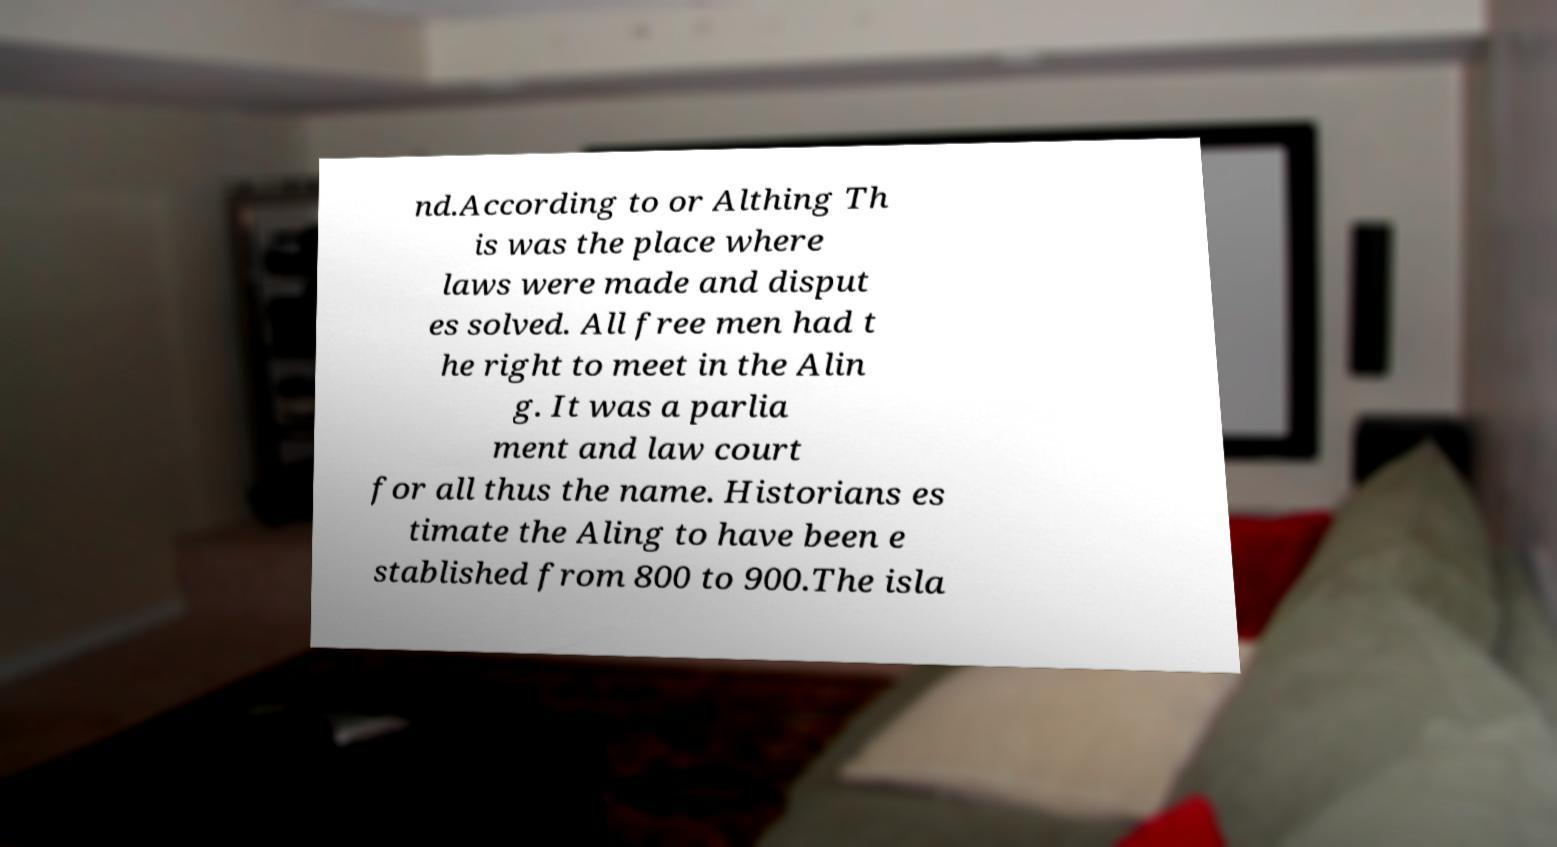What messages or text are displayed in this image? I need them in a readable, typed format. nd.According to or Althing Th is was the place where laws were made and disput es solved. All free men had t he right to meet in the Alin g. It was a parlia ment and law court for all thus the name. Historians es timate the Aling to have been e stablished from 800 to 900.The isla 